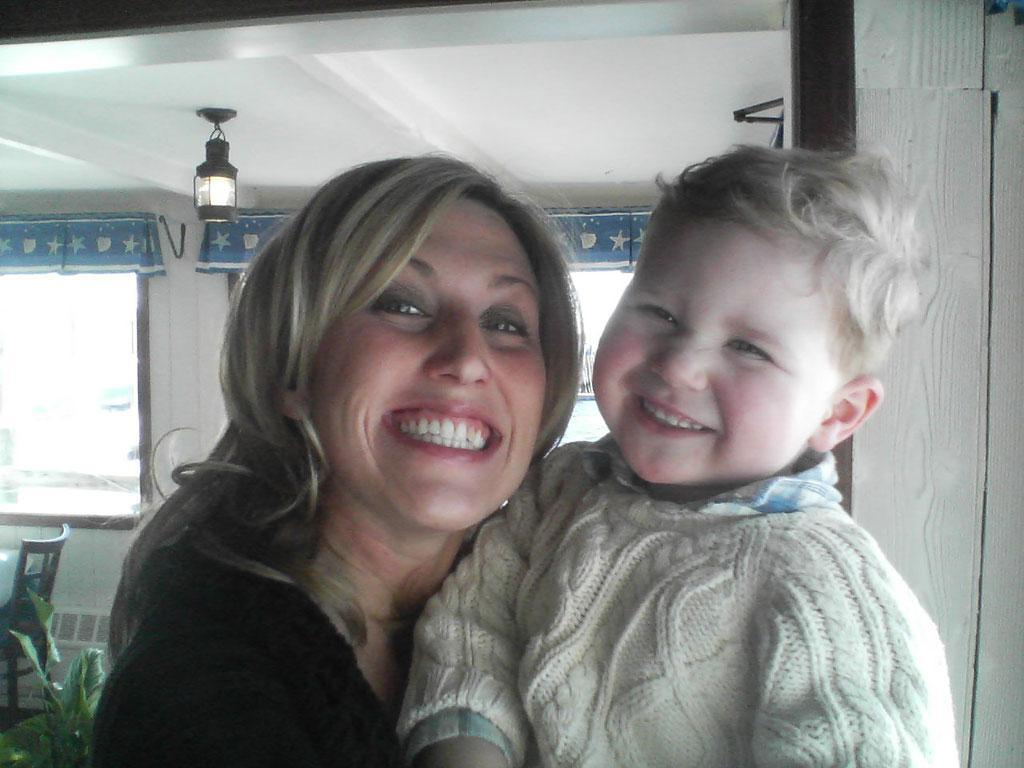Who is present in the image? There is a woman and a boy in the image. What expressions do the woman and the boy have? Both the woman and the boy are smiling in the image. What can be seen in the background of the image? There is a wall, windows, plants, and a chair in the background of the image. Is there any source of light visible in the image? Yes, there is a light visible at the top of the image. What type of string is being used to fold the sheet in the image? There is no string or sheet present in the image; it features a woman and a boy smiling, along with a background that includes a wall, windows, plants, and a chair. 